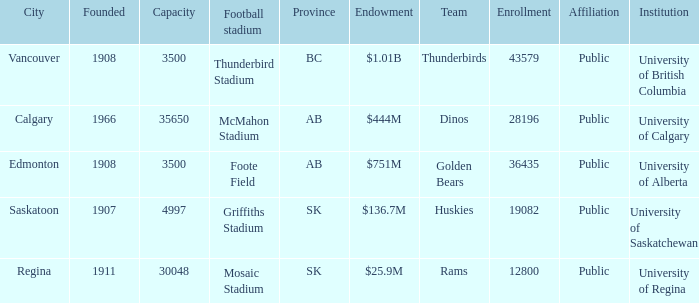Which institution has an endowment of $25.9m? University of Regina. 